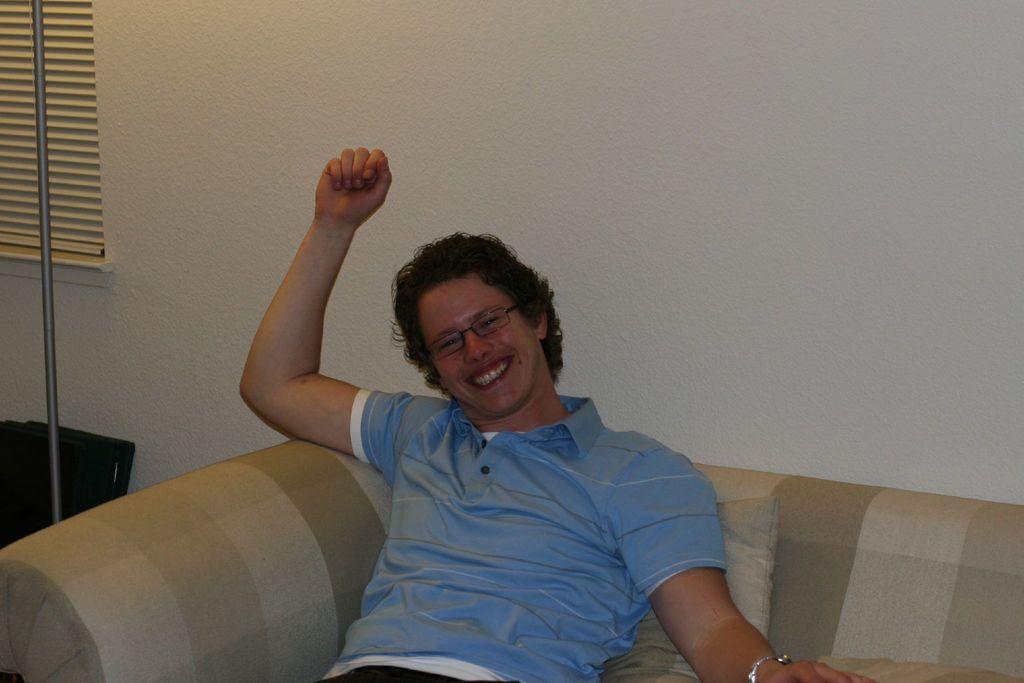Could you give a brief overview of what you see in this image? In this image we can see a person wearing the glasses and sitting on the sofa and smiling. We can also see the cushion, rod, window and also the plain wall. 